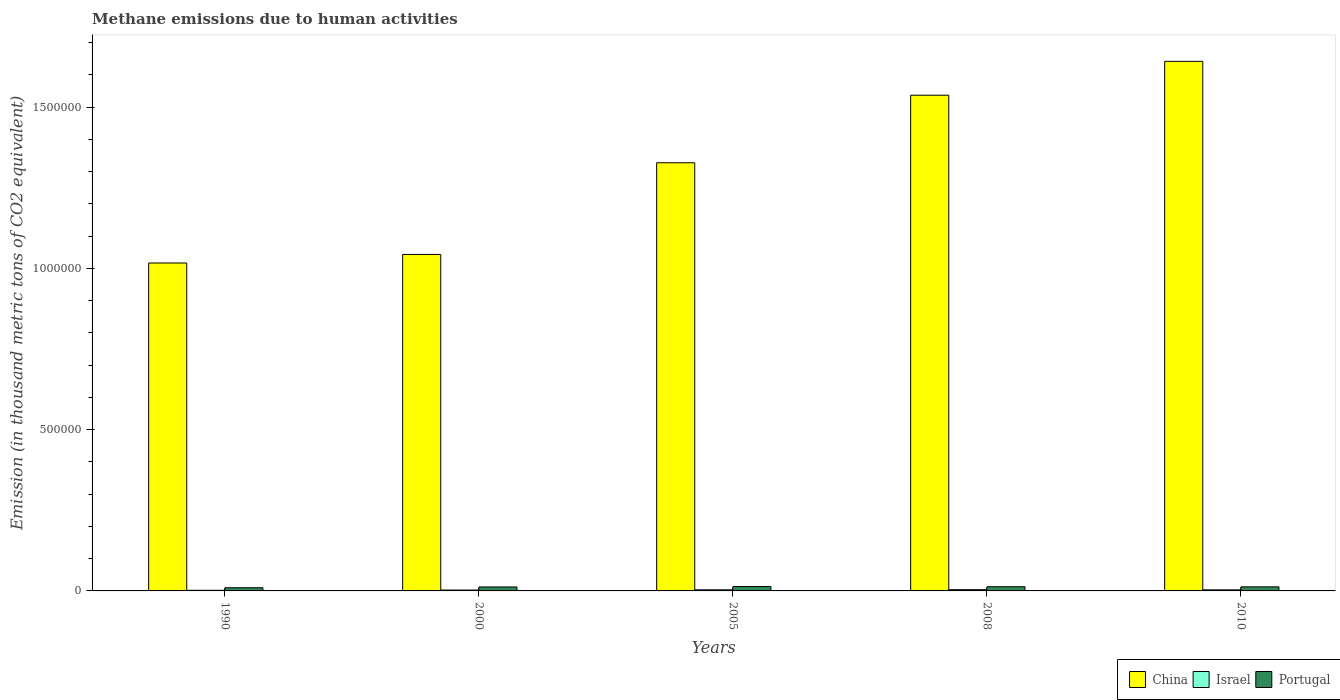How many different coloured bars are there?
Offer a very short reply. 3. How many groups of bars are there?
Offer a terse response. 5. How many bars are there on the 2nd tick from the right?
Ensure brevity in your answer.  3. What is the label of the 4th group of bars from the left?
Your answer should be very brief. 2008. In how many cases, is the number of bars for a given year not equal to the number of legend labels?
Make the answer very short. 0. What is the amount of methane emitted in Portugal in 1990?
Offer a very short reply. 9868.6. Across all years, what is the maximum amount of methane emitted in Portugal?
Offer a terse response. 1.36e+04. Across all years, what is the minimum amount of methane emitted in Portugal?
Make the answer very short. 9868.6. What is the total amount of methane emitted in China in the graph?
Offer a terse response. 6.57e+06. What is the difference between the amount of methane emitted in Israel in 2000 and that in 2010?
Make the answer very short. -651.3. What is the difference between the amount of methane emitted in China in 2008 and the amount of methane emitted in Israel in 2005?
Provide a short and direct response. 1.53e+06. What is the average amount of methane emitted in Israel per year?
Ensure brevity in your answer.  3066.1. In the year 2000, what is the difference between the amount of methane emitted in Israel and amount of methane emitted in Portugal?
Your answer should be very brief. -9590.3. In how many years, is the amount of methane emitted in China greater than 300000 thousand metric tons?
Provide a succinct answer. 5. What is the ratio of the amount of methane emitted in China in 1990 to that in 2010?
Your response must be concise. 0.62. What is the difference between the highest and the second highest amount of methane emitted in Israel?
Your answer should be very brief. 462. What is the difference between the highest and the lowest amount of methane emitted in China?
Make the answer very short. 6.25e+05. In how many years, is the amount of methane emitted in Portugal greater than the average amount of methane emitted in Portugal taken over all years?
Make the answer very short. 4. What does the 3rd bar from the right in 2008 represents?
Ensure brevity in your answer.  China. Is it the case that in every year, the sum of the amount of methane emitted in Israel and amount of methane emitted in Portugal is greater than the amount of methane emitted in China?
Keep it short and to the point. No. How many years are there in the graph?
Offer a terse response. 5. Are the values on the major ticks of Y-axis written in scientific E-notation?
Your answer should be compact. No. Does the graph contain any zero values?
Make the answer very short. No. Does the graph contain grids?
Make the answer very short. No. How are the legend labels stacked?
Provide a short and direct response. Horizontal. What is the title of the graph?
Provide a succinct answer. Methane emissions due to human activities. Does "Ukraine" appear as one of the legend labels in the graph?
Keep it short and to the point. No. What is the label or title of the X-axis?
Provide a short and direct response. Years. What is the label or title of the Y-axis?
Give a very brief answer. Emission (in thousand metric tons of CO2 equivalent). What is the Emission (in thousand metric tons of CO2 equivalent) in China in 1990?
Provide a succinct answer. 1.02e+06. What is the Emission (in thousand metric tons of CO2 equivalent) of Israel in 1990?
Give a very brief answer. 1913. What is the Emission (in thousand metric tons of CO2 equivalent) in Portugal in 1990?
Offer a terse response. 9868.6. What is the Emission (in thousand metric tons of CO2 equivalent) of China in 2000?
Make the answer very short. 1.04e+06. What is the Emission (in thousand metric tons of CO2 equivalent) in Israel in 2000?
Make the answer very short. 2698.8. What is the Emission (in thousand metric tons of CO2 equivalent) of Portugal in 2000?
Make the answer very short. 1.23e+04. What is the Emission (in thousand metric tons of CO2 equivalent) of China in 2005?
Ensure brevity in your answer.  1.33e+06. What is the Emission (in thousand metric tons of CO2 equivalent) in Israel in 2005?
Your response must be concise. 3453.3. What is the Emission (in thousand metric tons of CO2 equivalent) in Portugal in 2005?
Provide a succinct answer. 1.36e+04. What is the Emission (in thousand metric tons of CO2 equivalent) in China in 2008?
Your answer should be very brief. 1.54e+06. What is the Emission (in thousand metric tons of CO2 equivalent) of Israel in 2008?
Provide a short and direct response. 3915.3. What is the Emission (in thousand metric tons of CO2 equivalent) in Portugal in 2008?
Your answer should be very brief. 1.30e+04. What is the Emission (in thousand metric tons of CO2 equivalent) in China in 2010?
Offer a very short reply. 1.64e+06. What is the Emission (in thousand metric tons of CO2 equivalent) of Israel in 2010?
Provide a short and direct response. 3350.1. What is the Emission (in thousand metric tons of CO2 equivalent) in Portugal in 2010?
Your answer should be compact. 1.26e+04. Across all years, what is the maximum Emission (in thousand metric tons of CO2 equivalent) of China?
Offer a terse response. 1.64e+06. Across all years, what is the maximum Emission (in thousand metric tons of CO2 equivalent) in Israel?
Give a very brief answer. 3915.3. Across all years, what is the maximum Emission (in thousand metric tons of CO2 equivalent) of Portugal?
Offer a terse response. 1.36e+04. Across all years, what is the minimum Emission (in thousand metric tons of CO2 equivalent) in China?
Offer a very short reply. 1.02e+06. Across all years, what is the minimum Emission (in thousand metric tons of CO2 equivalent) of Israel?
Your answer should be compact. 1913. Across all years, what is the minimum Emission (in thousand metric tons of CO2 equivalent) in Portugal?
Give a very brief answer. 9868.6. What is the total Emission (in thousand metric tons of CO2 equivalent) of China in the graph?
Keep it short and to the point. 6.57e+06. What is the total Emission (in thousand metric tons of CO2 equivalent) in Israel in the graph?
Your response must be concise. 1.53e+04. What is the total Emission (in thousand metric tons of CO2 equivalent) in Portugal in the graph?
Offer a very short reply. 6.14e+04. What is the difference between the Emission (in thousand metric tons of CO2 equivalent) of China in 1990 and that in 2000?
Offer a terse response. -2.65e+04. What is the difference between the Emission (in thousand metric tons of CO2 equivalent) in Israel in 1990 and that in 2000?
Provide a succinct answer. -785.8. What is the difference between the Emission (in thousand metric tons of CO2 equivalent) of Portugal in 1990 and that in 2000?
Keep it short and to the point. -2420.5. What is the difference between the Emission (in thousand metric tons of CO2 equivalent) of China in 1990 and that in 2005?
Provide a succinct answer. -3.11e+05. What is the difference between the Emission (in thousand metric tons of CO2 equivalent) of Israel in 1990 and that in 2005?
Offer a terse response. -1540.3. What is the difference between the Emission (in thousand metric tons of CO2 equivalent) in Portugal in 1990 and that in 2005?
Offer a very short reply. -3778.3. What is the difference between the Emission (in thousand metric tons of CO2 equivalent) of China in 1990 and that in 2008?
Ensure brevity in your answer.  -5.20e+05. What is the difference between the Emission (in thousand metric tons of CO2 equivalent) in Israel in 1990 and that in 2008?
Your response must be concise. -2002.3. What is the difference between the Emission (in thousand metric tons of CO2 equivalent) in Portugal in 1990 and that in 2008?
Offer a terse response. -3158.3. What is the difference between the Emission (in thousand metric tons of CO2 equivalent) of China in 1990 and that in 2010?
Your answer should be very brief. -6.25e+05. What is the difference between the Emission (in thousand metric tons of CO2 equivalent) of Israel in 1990 and that in 2010?
Ensure brevity in your answer.  -1437.1. What is the difference between the Emission (in thousand metric tons of CO2 equivalent) in Portugal in 1990 and that in 2010?
Provide a succinct answer. -2731.9. What is the difference between the Emission (in thousand metric tons of CO2 equivalent) of China in 2000 and that in 2005?
Provide a succinct answer. -2.84e+05. What is the difference between the Emission (in thousand metric tons of CO2 equivalent) of Israel in 2000 and that in 2005?
Provide a short and direct response. -754.5. What is the difference between the Emission (in thousand metric tons of CO2 equivalent) in Portugal in 2000 and that in 2005?
Your answer should be very brief. -1357.8. What is the difference between the Emission (in thousand metric tons of CO2 equivalent) of China in 2000 and that in 2008?
Offer a terse response. -4.94e+05. What is the difference between the Emission (in thousand metric tons of CO2 equivalent) of Israel in 2000 and that in 2008?
Provide a succinct answer. -1216.5. What is the difference between the Emission (in thousand metric tons of CO2 equivalent) in Portugal in 2000 and that in 2008?
Keep it short and to the point. -737.8. What is the difference between the Emission (in thousand metric tons of CO2 equivalent) of China in 2000 and that in 2010?
Provide a short and direct response. -5.99e+05. What is the difference between the Emission (in thousand metric tons of CO2 equivalent) in Israel in 2000 and that in 2010?
Keep it short and to the point. -651.3. What is the difference between the Emission (in thousand metric tons of CO2 equivalent) of Portugal in 2000 and that in 2010?
Offer a terse response. -311.4. What is the difference between the Emission (in thousand metric tons of CO2 equivalent) in China in 2005 and that in 2008?
Your response must be concise. -2.09e+05. What is the difference between the Emission (in thousand metric tons of CO2 equivalent) in Israel in 2005 and that in 2008?
Your response must be concise. -462. What is the difference between the Emission (in thousand metric tons of CO2 equivalent) of Portugal in 2005 and that in 2008?
Provide a short and direct response. 620. What is the difference between the Emission (in thousand metric tons of CO2 equivalent) in China in 2005 and that in 2010?
Provide a succinct answer. -3.14e+05. What is the difference between the Emission (in thousand metric tons of CO2 equivalent) in Israel in 2005 and that in 2010?
Keep it short and to the point. 103.2. What is the difference between the Emission (in thousand metric tons of CO2 equivalent) of Portugal in 2005 and that in 2010?
Your response must be concise. 1046.4. What is the difference between the Emission (in thousand metric tons of CO2 equivalent) in China in 2008 and that in 2010?
Ensure brevity in your answer.  -1.05e+05. What is the difference between the Emission (in thousand metric tons of CO2 equivalent) in Israel in 2008 and that in 2010?
Provide a short and direct response. 565.2. What is the difference between the Emission (in thousand metric tons of CO2 equivalent) in Portugal in 2008 and that in 2010?
Your answer should be compact. 426.4. What is the difference between the Emission (in thousand metric tons of CO2 equivalent) in China in 1990 and the Emission (in thousand metric tons of CO2 equivalent) in Israel in 2000?
Give a very brief answer. 1.01e+06. What is the difference between the Emission (in thousand metric tons of CO2 equivalent) of China in 1990 and the Emission (in thousand metric tons of CO2 equivalent) of Portugal in 2000?
Offer a terse response. 1.00e+06. What is the difference between the Emission (in thousand metric tons of CO2 equivalent) of Israel in 1990 and the Emission (in thousand metric tons of CO2 equivalent) of Portugal in 2000?
Offer a very short reply. -1.04e+04. What is the difference between the Emission (in thousand metric tons of CO2 equivalent) of China in 1990 and the Emission (in thousand metric tons of CO2 equivalent) of Israel in 2005?
Keep it short and to the point. 1.01e+06. What is the difference between the Emission (in thousand metric tons of CO2 equivalent) in China in 1990 and the Emission (in thousand metric tons of CO2 equivalent) in Portugal in 2005?
Your answer should be compact. 1.00e+06. What is the difference between the Emission (in thousand metric tons of CO2 equivalent) of Israel in 1990 and the Emission (in thousand metric tons of CO2 equivalent) of Portugal in 2005?
Provide a succinct answer. -1.17e+04. What is the difference between the Emission (in thousand metric tons of CO2 equivalent) of China in 1990 and the Emission (in thousand metric tons of CO2 equivalent) of Israel in 2008?
Your answer should be compact. 1.01e+06. What is the difference between the Emission (in thousand metric tons of CO2 equivalent) in China in 1990 and the Emission (in thousand metric tons of CO2 equivalent) in Portugal in 2008?
Your answer should be very brief. 1.00e+06. What is the difference between the Emission (in thousand metric tons of CO2 equivalent) in Israel in 1990 and the Emission (in thousand metric tons of CO2 equivalent) in Portugal in 2008?
Offer a terse response. -1.11e+04. What is the difference between the Emission (in thousand metric tons of CO2 equivalent) in China in 1990 and the Emission (in thousand metric tons of CO2 equivalent) in Israel in 2010?
Offer a terse response. 1.01e+06. What is the difference between the Emission (in thousand metric tons of CO2 equivalent) in China in 1990 and the Emission (in thousand metric tons of CO2 equivalent) in Portugal in 2010?
Offer a terse response. 1.00e+06. What is the difference between the Emission (in thousand metric tons of CO2 equivalent) in Israel in 1990 and the Emission (in thousand metric tons of CO2 equivalent) in Portugal in 2010?
Keep it short and to the point. -1.07e+04. What is the difference between the Emission (in thousand metric tons of CO2 equivalent) of China in 2000 and the Emission (in thousand metric tons of CO2 equivalent) of Israel in 2005?
Offer a very short reply. 1.04e+06. What is the difference between the Emission (in thousand metric tons of CO2 equivalent) in China in 2000 and the Emission (in thousand metric tons of CO2 equivalent) in Portugal in 2005?
Give a very brief answer. 1.03e+06. What is the difference between the Emission (in thousand metric tons of CO2 equivalent) of Israel in 2000 and the Emission (in thousand metric tons of CO2 equivalent) of Portugal in 2005?
Keep it short and to the point. -1.09e+04. What is the difference between the Emission (in thousand metric tons of CO2 equivalent) in China in 2000 and the Emission (in thousand metric tons of CO2 equivalent) in Israel in 2008?
Your response must be concise. 1.04e+06. What is the difference between the Emission (in thousand metric tons of CO2 equivalent) in China in 2000 and the Emission (in thousand metric tons of CO2 equivalent) in Portugal in 2008?
Your answer should be very brief. 1.03e+06. What is the difference between the Emission (in thousand metric tons of CO2 equivalent) in Israel in 2000 and the Emission (in thousand metric tons of CO2 equivalent) in Portugal in 2008?
Your answer should be compact. -1.03e+04. What is the difference between the Emission (in thousand metric tons of CO2 equivalent) in China in 2000 and the Emission (in thousand metric tons of CO2 equivalent) in Israel in 2010?
Make the answer very short. 1.04e+06. What is the difference between the Emission (in thousand metric tons of CO2 equivalent) of China in 2000 and the Emission (in thousand metric tons of CO2 equivalent) of Portugal in 2010?
Offer a very short reply. 1.03e+06. What is the difference between the Emission (in thousand metric tons of CO2 equivalent) of Israel in 2000 and the Emission (in thousand metric tons of CO2 equivalent) of Portugal in 2010?
Provide a short and direct response. -9901.7. What is the difference between the Emission (in thousand metric tons of CO2 equivalent) of China in 2005 and the Emission (in thousand metric tons of CO2 equivalent) of Israel in 2008?
Provide a short and direct response. 1.32e+06. What is the difference between the Emission (in thousand metric tons of CO2 equivalent) in China in 2005 and the Emission (in thousand metric tons of CO2 equivalent) in Portugal in 2008?
Offer a very short reply. 1.31e+06. What is the difference between the Emission (in thousand metric tons of CO2 equivalent) of Israel in 2005 and the Emission (in thousand metric tons of CO2 equivalent) of Portugal in 2008?
Your response must be concise. -9573.6. What is the difference between the Emission (in thousand metric tons of CO2 equivalent) of China in 2005 and the Emission (in thousand metric tons of CO2 equivalent) of Israel in 2010?
Provide a short and direct response. 1.32e+06. What is the difference between the Emission (in thousand metric tons of CO2 equivalent) of China in 2005 and the Emission (in thousand metric tons of CO2 equivalent) of Portugal in 2010?
Your response must be concise. 1.32e+06. What is the difference between the Emission (in thousand metric tons of CO2 equivalent) of Israel in 2005 and the Emission (in thousand metric tons of CO2 equivalent) of Portugal in 2010?
Ensure brevity in your answer.  -9147.2. What is the difference between the Emission (in thousand metric tons of CO2 equivalent) of China in 2008 and the Emission (in thousand metric tons of CO2 equivalent) of Israel in 2010?
Make the answer very short. 1.53e+06. What is the difference between the Emission (in thousand metric tons of CO2 equivalent) in China in 2008 and the Emission (in thousand metric tons of CO2 equivalent) in Portugal in 2010?
Give a very brief answer. 1.52e+06. What is the difference between the Emission (in thousand metric tons of CO2 equivalent) of Israel in 2008 and the Emission (in thousand metric tons of CO2 equivalent) of Portugal in 2010?
Keep it short and to the point. -8685.2. What is the average Emission (in thousand metric tons of CO2 equivalent) in China per year?
Your response must be concise. 1.31e+06. What is the average Emission (in thousand metric tons of CO2 equivalent) of Israel per year?
Provide a short and direct response. 3066.1. What is the average Emission (in thousand metric tons of CO2 equivalent) in Portugal per year?
Your answer should be very brief. 1.23e+04. In the year 1990, what is the difference between the Emission (in thousand metric tons of CO2 equivalent) in China and Emission (in thousand metric tons of CO2 equivalent) in Israel?
Provide a short and direct response. 1.02e+06. In the year 1990, what is the difference between the Emission (in thousand metric tons of CO2 equivalent) of China and Emission (in thousand metric tons of CO2 equivalent) of Portugal?
Your answer should be compact. 1.01e+06. In the year 1990, what is the difference between the Emission (in thousand metric tons of CO2 equivalent) of Israel and Emission (in thousand metric tons of CO2 equivalent) of Portugal?
Your answer should be very brief. -7955.6. In the year 2000, what is the difference between the Emission (in thousand metric tons of CO2 equivalent) in China and Emission (in thousand metric tons of CO2 equivalent) in Israel?
Make the answer very short. 1.04e+06. In the year 2000, what is the difference between the Emission (in thousand metric tons of CO2 equivalent) in China and Emission (in thousand metric tons of CO2 equivalent) in Portugal?
Your answer should be compact. 1.03e+06. In the year 2000, what is the difference between the Emission (in thousand metric tons of CO2 equivalent) in Israel and Emission (in thousand metric tons of CO2 equivalent) in Portugal?
Your answer should be very brief. -9590.3. In the year 2005, what is the difference between the Emission (in thousand metric tons of CO2 equivalent) in China and Emission (in thousand metric tons of CO2 equivalent) in Israel?
Your response must be concise. 1.32e+06. In the year 2005, what is the difference between the Emission (in thousand metric tons of CO2 equivalent) in China and Emission (in thousand metric tons of CO2 equivalent) in Portugal?
Your answer should be very brief. 1.31e+06. In the year 2005, what is the difference between the Emission (in thousand metric tons of CO2 equivalent) in Israel and Emission (in thousand metric tons of CO2 equivalent) in Portugal?
Your response must be concise. -1.02e+04. In the year 2008, what is the difference between the Emission (in thousand metric tons of CO2 equivalent) in China and Emission (in thousand metric tons of CO2 equivalent) in Israel?
Your response must be concise. 1.53e+06. In the year 2008, what is the difference between the Emission (in thousand metric tons of CO2 equivalent) of China and Emission (in thousand metric tons of CO2 equivalent) of Portugal?
Offer a terse response. 1.52e+06. In the year 2008, what is the difference between the Emission (in thousand metric tons of CO2 equivalent) of Israel and Emission (in thousand metric tons of CO2 equivalent) of Portugal?
Provide a succinct answer. -9111.6. In the year 2010, what is the difference between the Emission (in thousand metric tons of CO2 equivalent) in China and Emission (in thousand metric tons of CO2 equivalent) in Israel?
Keep it short and to the point. 1.64e+06. In the year 2010, what is the difference between the Emission (in thousand metric tons of CO2 equivalent) of China and Emission (in thousand metric tons of CO2 equivalent) of Portugal?
Provide a succinct answer. 1.63e+06. In the year 2010, what is the difference between the Emission (in thousand metric tons of CO2 equivalent) of Israel and Emission (in thousand metric tons of CO2 equivalent) of Portugal?
Provide a short and direct response. -9250.4. What is the ratio of the Emission (in thousand metric tons of CO2 equivalent) of China in 1990 to that in 2000?
Offer a terse response. 0.97. What is the ratio of the Emission (in thousand metric tons of CO2 equivalent) of Israel in 1990 to that in 2000?
Your answer should be very brief. 0.71. What is the ratio of the Emission (in thousand metric tons of CO2 equivalent) in Portugal in 1990 to that in 2000?
Your answer should be very brief. 0.8. What is the ratio of the Emission (in thousand metric tons of CO2 equivalent) in China in 1990 to that in 2005?
Give a very brief answer. 0.77. What is the ratio of the Emission (in thousand metric tons of CO2 equivalent) of Israel in 1990 to that in 2005?
Give a very brief answer. 0.55. What is the ratio of the Emission (in thousand metric tons of CO2 equivalent) in Portugal in 1990 to that in 2005?
Provide a succinct answer. 0.72. What is the ratio of the Emission (in thousand metric tons of CO2 equivalent) of China in 1990 to that in 2008?
Provide a succinct answer. 0.66. What is the ratio of the Emission (in thousand metric tons of CO2 equivalent) of Israel in 1990 to that in 2008?
Provide a succinct answer. 0.49. What is the ratio of the Emission (in thousand metric tons of CO2 equivalent) in Portugal in 1990 to that in 2008?
Your answer should be very brief. 0.76. What is the ratio of the Emission (in thousand metric tons of CO2 equivalent) of China in 1990 to that in 2010?
Your answer should be very brief. 0.62. What is the ratio of the Emission (in thousand metric tons of CO2 equivalent) in Israel in 1990 to that in 2010?
Keep it short and to the point. 0.57. What is the ratio of the Emission (in thousand metric tons of CO2 equivalent) in Portugal in 1990 to that in 2010?
Ensure brevity in your answer.  0.78. What is the ratio of the Emission (in thousand metric tons of CO2 equivalent) in China in 2000 to that in 2005?
Your response must be concise. 0.79. What is the ratio of the Emission (in thousand metric tons of CO2 equivalent) in Israel in 2000 to that in 2005?
Provide a short and direct response. 0.78. What is the ratio of the Emission (in thousand metric tons of CO2 equivalent) of Portugal in 2000 to that in 2005?
Ensure brevity in your answer.  0.9. What is the ratio of the Emission (in thousand metric tons of CO2 equivalent) of China in 2000 to that in 2008?
Your response must be concise. 0.68. What is the ratio of the Emission (in thousand metric tons of CO2 equivalent) in Israel in 2000 to that in 2008?
Provide a short and direct response. 0.69. What is the ratio of the Emission (in thousand metric tons of CO2 equivalent) in Portugal in 2000 to that in 2008?
Offer a terse response. 0.94. What is the ratio of the Emission (in thousand metric tons of CO2 equivalent) of China in 2000 to that in 2010?
Your response must be concise. 0.64. What is the ratio of the Emission (in thousand metric tons of CO2 equivalent) in Israel in 2000 to that in 2010?
Your response must be concise. 0.81. What is the ratio of the Emission (in thousand metric tons of CO2 equivalent) of Portugal in 2000 to that in 2010?
Offer a terse response. 0.98. What is the ratio of the Emission (in thousand metric tons of CO2 equivalent) in China in 2005 to that in 2008?
Give a very brief answer. 0.86. What is the ratio of the Emission (in thousand metric tons of CO2 equivalent) of Israel in 2005 to that in 2008?
Give a very brief answer. 0.88. What is the ratio of the Emission (in thousand metric tons of CO2 equivalent) in Portugal in 2005 to that in 2008?
Give a very brief answer. 1.05. What is the ratio of the Emission (in thousand metric tons of CO2 equivalent) in China in 2005 to that in 2010?
Provide a succinct answer. 0.81. What is the ratio of the Emission (in thousand metric tons of CO2 equivalent) in Israel in 2005 to that in 2010?
Keep it short and to the point. 1.03. What is the ratio of the Emission (in thousand metric tons of CO2 equivalent) in Portugal in 2005 to that in 2010?
Provide a short and direct response. 1.08. What is the ratio of the Emission (in thousand metric tons of CO2 equivalent) of China in 2008 to that in 2010?
Your answer should be very brief. 0.94. What is the ratio of the Emission (in thousand metric tons of CO2 equivalent) of Israel in 2008 to that in 2010?
Keep it short and to the point. 1.17. What is the ratio of the Emission (in thousand metric tons of CO2 equivalent) in Portugal in 2008 to that in 2010?
Your answer should be very brief. 1.03. What is the difference between the highest and the second highest Emission (in thousand metric tons of CO2 equivalent) of China?
Provide a succinct answer. 1.05e+05. What is the difference between the highest and the second highest Emission (in thousand metric tons of CO2 equivalent) in Israel?
Make the answer very short. 462. What is the difference between the highest and the second highest Emission (in thousand metric tons of CO2 equivalent) of Portugal?
Provide a short and direct response. 620. What is the difference between the highest and the lowest Emission (in thousand metric tons of CO2 equivalent) in China?
Offer a very short reply. 6.25e+05. What is the difference between the highest and the lowest Emission (in thousand metric tons of CO2 equivalent) in Israel?
Provide a succinct answer. 2002.3. What is the difference between the highest and the lowest Emission (in thousand metric tons of CO2 equivalent) of Portugal?
Your answer should be compact. 3778.3. 